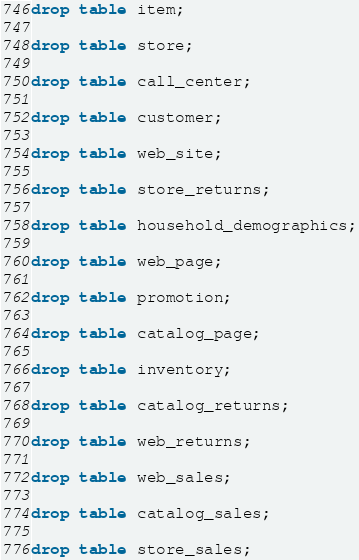Convert code to text. <code><loc_0><loc_0><loc_500><loc_500><_SQL_>
drop table item;

drop table store;

drop table call_center;

drop table customer;

drop table web_site;

drop table store_returns;

drop table household_demographics;

drop table web_page;

drop table promotion;

drop table catalog_page;

drop table inventory;

drop table catalog_returns;

drop table web_returns;

drop table web_sales;

drop table catalog_sales;

drop table store_sales;

</code> 